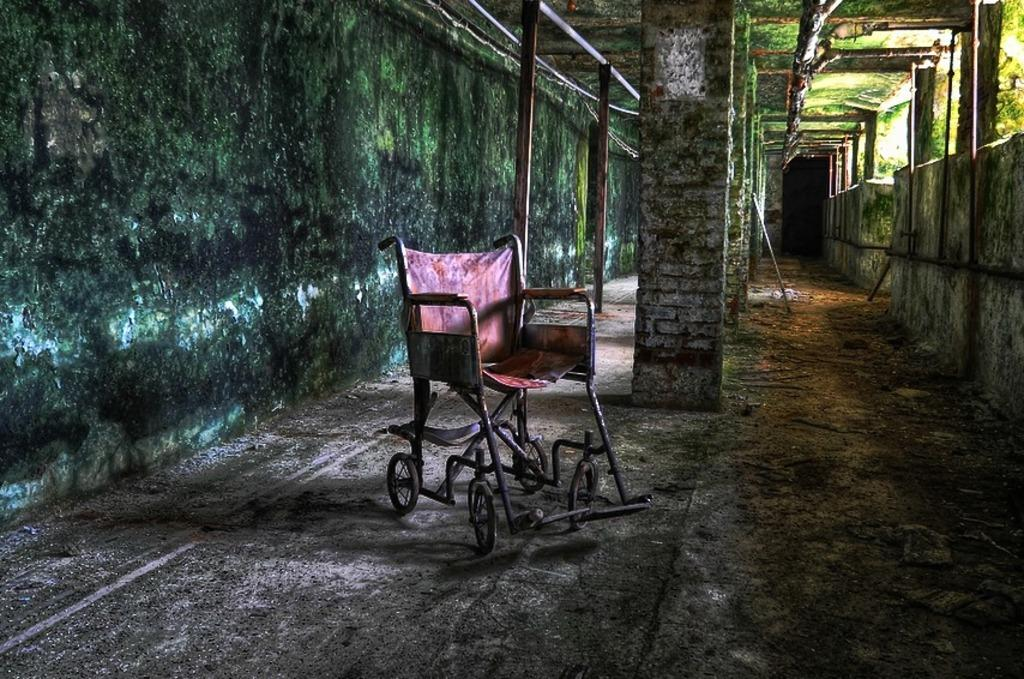What type of furniture is present in the image? There is a chair in the image. What can be seen on the ground in the image? The ground is visible in the image with some objects. Are there any architectural features in the image? Yes, there are pillars in the image. What is on the wall in the image? There is a wall with algae in the image. What else can be seen in the image besides the chair and wall? There are a few poles and the roof is visible in the image. What type of tin can be seen hanging from the poles in the image? There is no tin present in the image; it only mentions poles and other architectural features. 